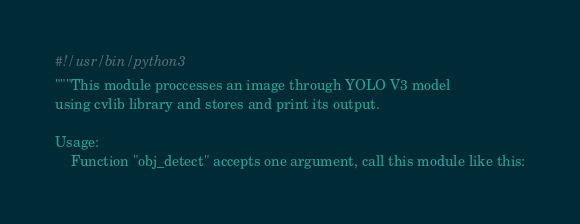<code> <loc_0><loc_0><loc_500><loc_500><_Python_>#!/usr/bin/python3
"""This module proccesses an image through YOLO V3 model
using cvlib library and stores and print its output.

Usage:
    Function "obj_detect" accepts one argument, call this module like this:</code> 